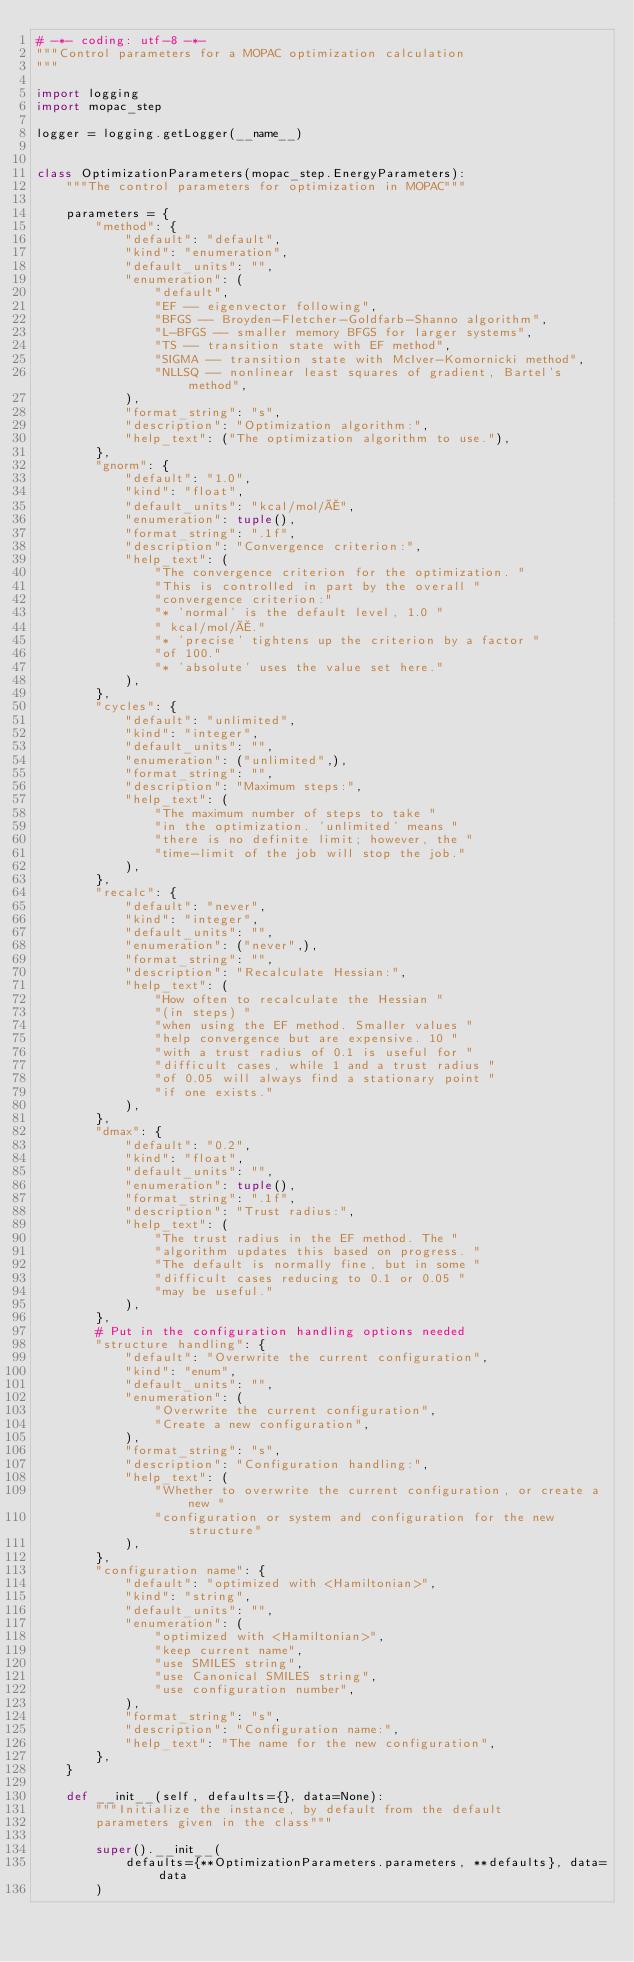Convert code to text. <code><loc_0><loc_0><loc_500><loc_500><_Python_># -*- coding: utf-8 -*-
"""Control parameters for a MOPAC optimization calculation
"""

import logging
import mopac_step

logger = logging.getLogger(__name__)


class OptimizationParameters(mopac_step.EnergyParameters):
    """The control parameters for optimization in MOPAC"""

    parameters = {
        "method": {
            "default": "default",
            "kind": "enumeration",
            "default_units": "",
            "enumeration": (
                "default",
                "EF -- eigenvector following",
                "BFGS -- Broyden-Fletcher-Goldfarb-Shanno algorithm",
                "L-BFGS -- smaller memory BFGS for larger systems",
                "TS -- transition state with EF method",
                "SIGMA -- transition state with McIver-Komornicki method",
                "NLLSQ -- nonlinear least squares of gradient, Bartel's method",
            ),
            "format_string": "s",
            "description": "Optimization algorithm:",
            "help_text": ("The optimization algorithm to use."),
        },
        "gnorm": {
            "default": "1.0",
            "kind": "float",
            "default_units": "kcal/mol/Å",
            "enumeration": tuple(),
            "format_string": ".1f",
            "description": "Convergence criterion:",
            "help_text": (
                "The convergence criterion for the optimization. "
                "This is controlled in part by the overall "
                "convergence criterion:"
                "* 'normal' is the default level, 1.0 "
                " kcal/mol/Å."
                "* 'precise' tightens up the criterion by a factor "
                "of 100."
                "* 'absolute' uses the value set here."
            ),
        },
        "cycles": {
            "default": "unlimited",
            "kind": "integer",
            "default_units": "",
            "enumeration": ("unlimited",),
            "format_string": "",
            "description": "Maximum steps:",
            "help_text": (
                "The maximum number of steps to take "
                "in the optimization. 'unlimited' means "
                "there is no definite limit; however, the "
                "time-limit of the job will stop the job."
            ),
        },
        "recalc": {
            "default": "never",
            "kind": "integer",
            "default_units": "",
            "enumeration": ("never",),
            "format_string": "",
            "description": "Recalculate Hessian:",
            "help_text": (
                "How often to recalculate the Hessian "
                "(in steps) "
                "when using the EF method. Smaller values "
                "help convergence but are expensive. 10 "
                "with a trust radius of 0.1 is useful for "
                "difficult cases, while 1 and a trust radius "
                "of 0.05 will always find a stationary point "
                "if one exists."
            ),
        },
        "dmax": {
            "default": "0.2",
            "kind": "float",
            "default_units": "",
            "enumeration": tuple(),
            "format_string": ".1f",
            "description": "Trust radius:",
            "help_text": (
                "The trust radius in the EF method. The "
                "algorithm updates this based on progress. "
                "The default is normally fine, but in some "
                "difficult cases reducing to 0.1 or 0.05 "
                "may be useful."
            ),
        },
        # Put in the configuration handling options needed
        "structure handling": {
            "default": "Overwrite the current configuration",
            "kind": "enum",
            "default_units": "",
            "enumeration": (
                "Overwrite the current configuration",
                "Create a new configuration",
            ),
            "format_string": "s",
            "description": "Configuration handling:",
            "help_text": (
                "Whether to overwrite the current configuration, or create a new "
                "configuration or system and configuration for the new structure"
            ),
        },
        "configuration name": {
            "default": "optimized with <Hamiltonian>",
            "kind": "string",
            "default_units": "",
            "enumeration": (
                "optimized with <Hamiltonian>",
                "keep current name",
                "use SMILES string",
                "use Canonical SMILES string",
                "use configuration number",
            ),
            "format_string": "s",
            "description": "Configuration name:",
            "help_text": "The name for the new configuration",
        },
    }

    def __init__(self, defaults={}, data=None):
        """Initialize the instance, by default from the default
        parameters given in the class"""

        super().__init__(
            defaults={**OptimizationParameters.parameters, **defaults}, data=data
        )
</code> 